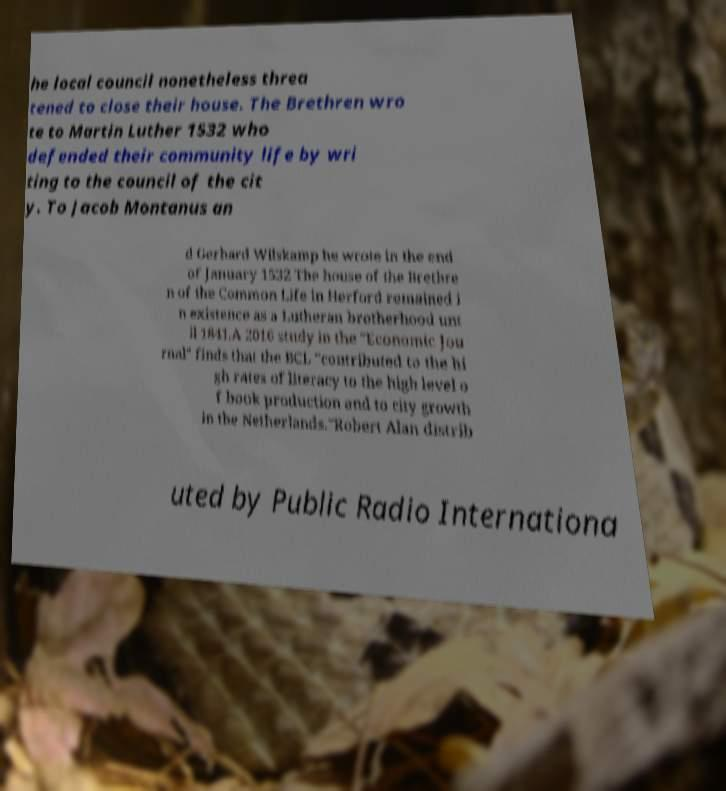I need the written content from this picture converted into text. Can you do that? he local council nonetheless threa tened to close their house. The Brethren wro te to Martin Luther 1532 who defended their community life by wri ting to the council of the cit y. To Jacob Montanus an d Gerhard Wilskamp he wrote in the end of January 1532 The house of the Brethre n of the Common Life in Herford remained i n existence as a Lutheran brotherhood unt il 1841.A 2016 study in the "Economic Jou rnal" finds that the BCL "contributed to the hi gh rates of literacy to the high level o f book production and to city growth in the Netherlands."Robert Alan distrib uted by Public Radio Internationa 